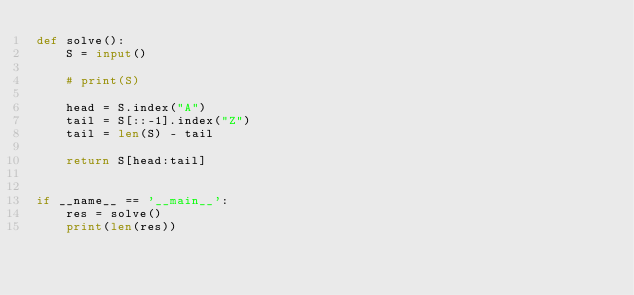Convert code to text. <code><loc_0><loc_0><loc_500><loc_500><_Python_>def solve():
    S = input()

    # print(S)

    head = S.index("A")
    tail = S[::-1].index("Z")
    tail = len(S) - tail

    return S[head:tail]


if __name__ == '__main__':
    res = solve()
    print(len(res))
</code> 